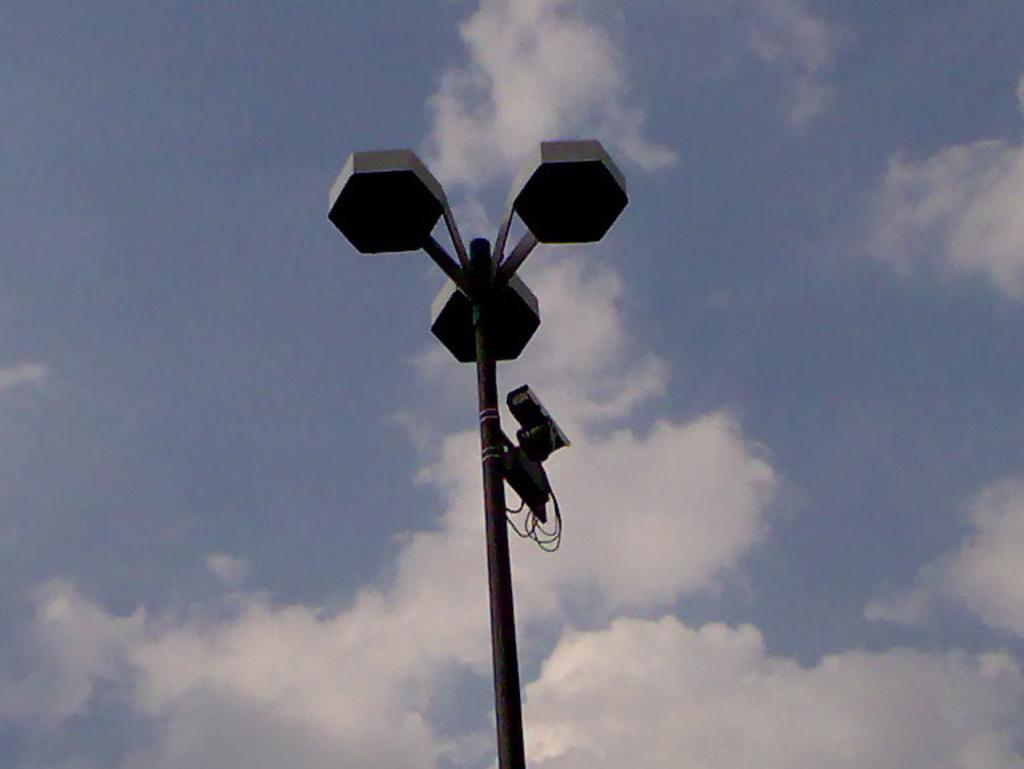What is located in the middle of the image? There is a street light, a pole, a camera, and electric wires in the middle of the image. What can be seen in the background of the image? The sky is visible in the background of the image. How would you describe the sky in the image? The sky is slightly cloudy. How many geese are resting on the waste in the image? There are no geese or waste present in the image. What type of home is visible in the image? There is no home visible in the image. 